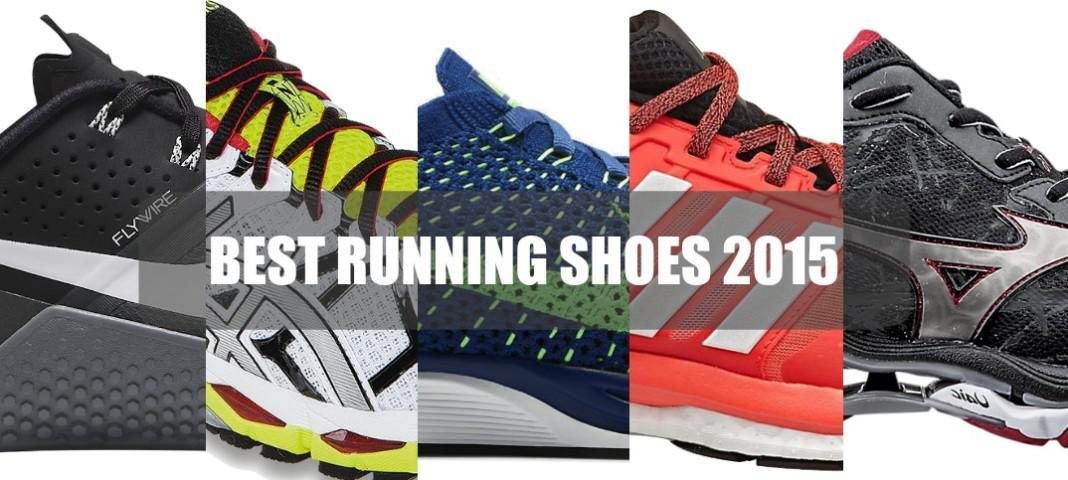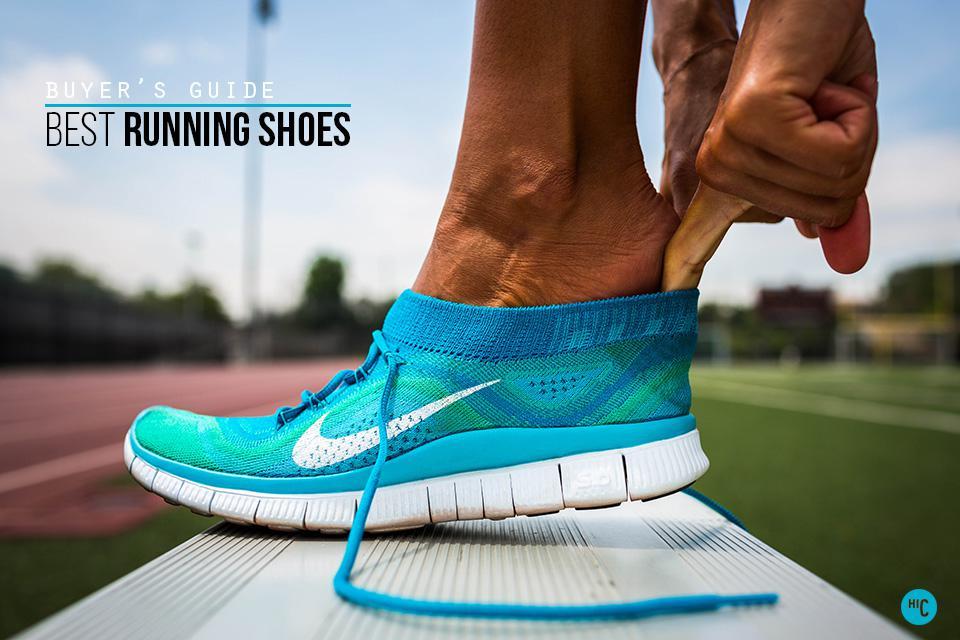The first image is the image on the left, the second image is the image on the right. Analyze the images presented: Is the assertion "A person is shown with at least one show in the image on the right." valid? Answer yes or no. Yes. The first image is the image on the left, the second image is the image on the right. For the images shown, is this caption "A human foot is present in an image with at least one sneaker also present." true? Answer yes or no. Yes. 